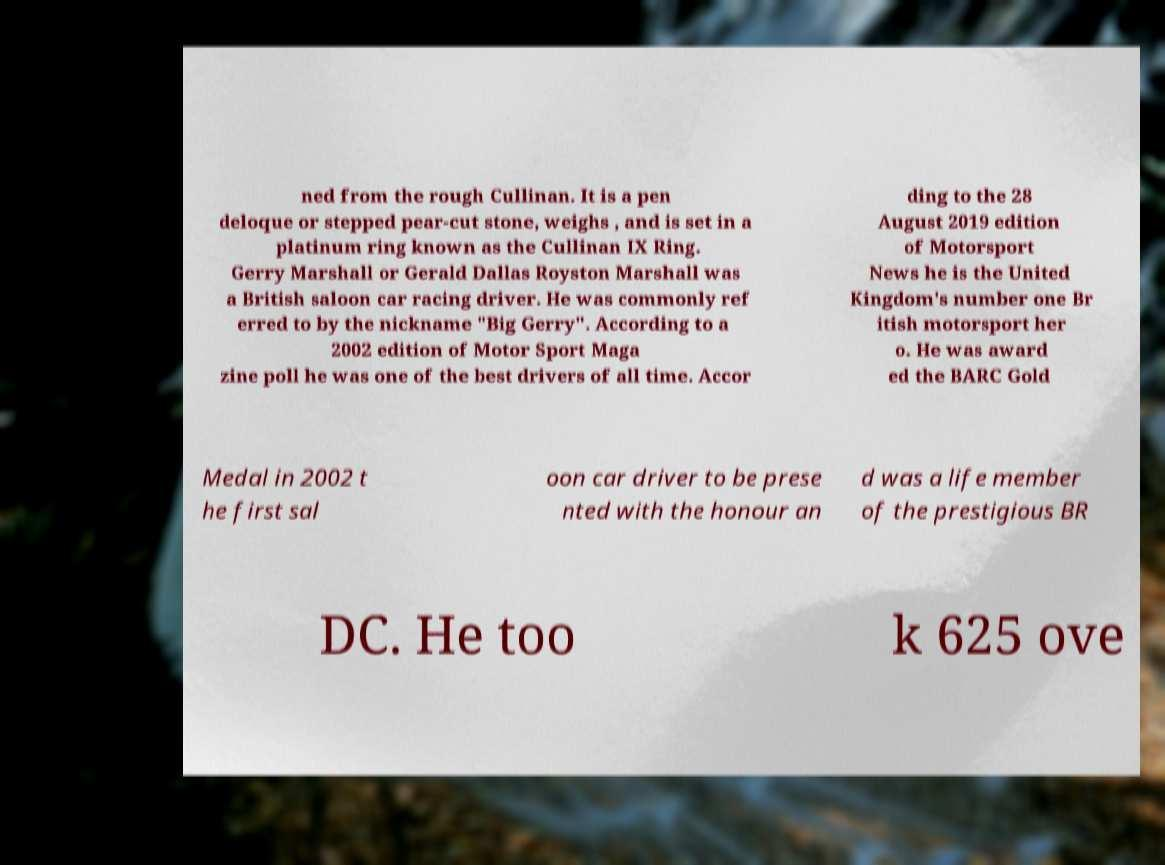Please identify and transcribe the text found in this image. ned from the rough Cullinan. It is a pen deloque or stepped pear-cut stone, weighs , and is set in a platinum ring known as the Cullinan IX Ring. Gerry Marshall or Gerald Dallas Royston Marshall was a British saloon car racing driver. He was commonly ref erred to by the nickname "Big Gerry". According to a 2002 edition of Motor Sport Maga zine poll he was one of the best drivers of all time. Accor ding to the 28 August 2019 edition of Motorsport News he is the United Kingdom's number one Br itish motorsport her o. He was award ed the BARC Gold Medal in 2002 t he first sal oon car driver to be prese nted with the honour an d was a life member of the prestigious BR DC. He too k 625 ove 